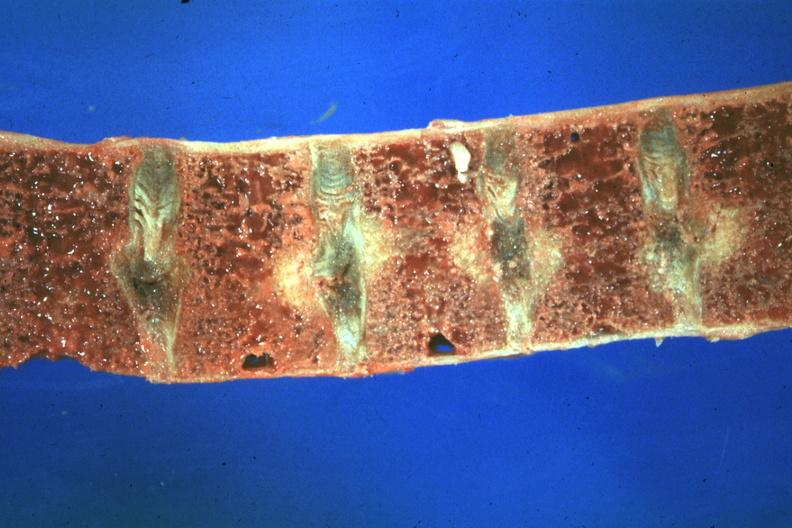does this image show close-up view very good case of 48yowm with hypertension renal failure and secondary parathyroid hyperplasia?
Answer the question using a single word or phrase. Yes 